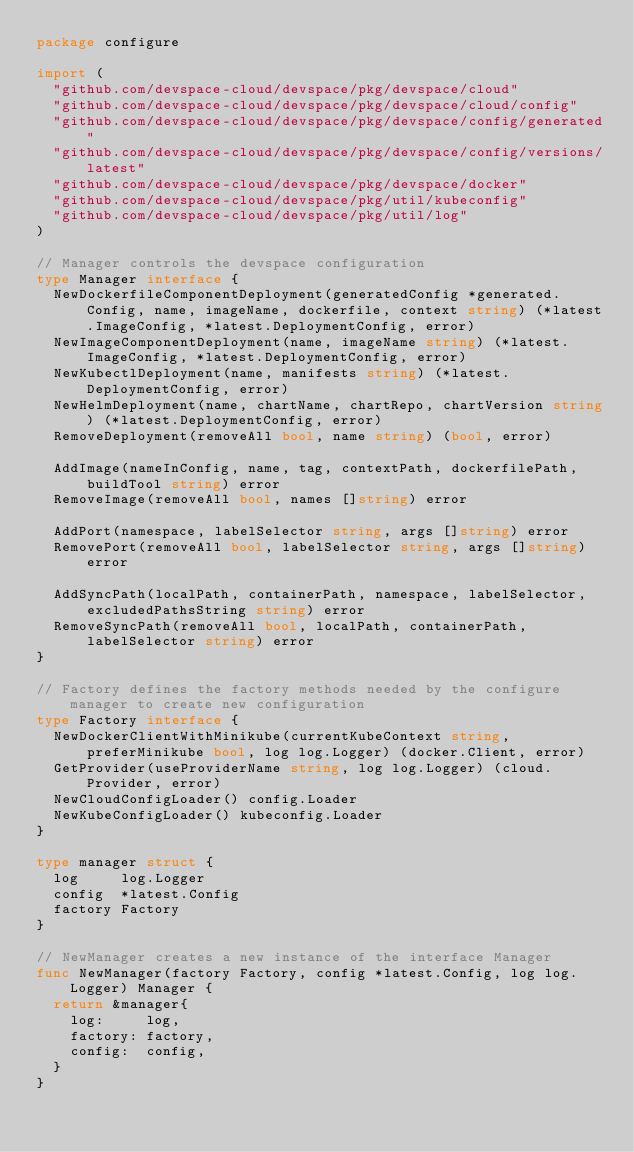<code> <loc_0><loc_0><loc_500><loc_500><_Go_>package configure

import (
	"github.com/devspace-cloud/devspace/pkg/devspace/cloud"
	"github.com/devspace-cloud/devspace/pkg/devspace/cloud/config"
	"github.com/devspace-cloud/devspace/pkg/devspace/config/generated"
	"github.com/devspace-cloud/devspace/pkg/devspace/config/versions/latest"
	"github.com/devspace-cloud/devspace/pkg/devspace/docker"
	"github.com/devspace-cloud/devspace/pkg/util/kubeconfig"
	"github.com/devspace-cloud/devspace/pkg/util/log"
)

// Manager controls the devspace configuration
type Manager interface {
	NewDockerfileComponentDeployment(generatedConfig *generated.Config, name, imageName, dockerfile, context string) (*latest.ImageConfig, *latest.DeploymentConfig, error)
	NewImageComponentDeployment(name, imageName string) (*latest.ImageConfig, *latest.DeploymentConfig, error)
	NewKubectlDeployment(name, manifests string) (*latest.DeploymentConfig, error)
	NewHelmDeployment(name, chartName, chartRepo, chartVersion string) (*latest.DeploymentConfig, error)
	RemoveDeployment(removeAll bool, name string) (bool, error)

	AddImage(nameInConfig, name, tag, contextPath, dockerfilePath, buildTool string) error
	RemoveImage(removeAll bool, names []string) error

	AddPort(namespace, labelSelector string, args []string) error
	RemovePort(removeAll bool, labelSelector string, args []string) error

	AddSyncPath(localPath, containerPath, namespace, labelSelector, excludedPathsString string) error
	RemoveSyncPath(removeAll bool, localPath, containerPath, labelSelector string) error
}

// Factory defines the factory methods needed by the configure manager to create new configuration
type Factory interface {
	NewDockerClientWithMinikube(currentKubeContext string, preferMinikube bool, log log.Logger) (docker.Client, error)
	GetProvider(useProviderName string, log log.Logger) (cloud.Provider, error)
	NewCloudConfigLoader() config.Loader
	NewKubeConfigLoader() kubeconfig.Loader
}

type manager struct {
	log     log.Logger
	config  *latest.Config
	factory Factory
}

// NewManager creates a new instance of the interface Manager
func NewManager(factory Factory, config *latest.Config, log log.Logger) Manager {
	return &manager{
		log:     log,
		factory: factory,
		config:  config,
	}
}
</code> 